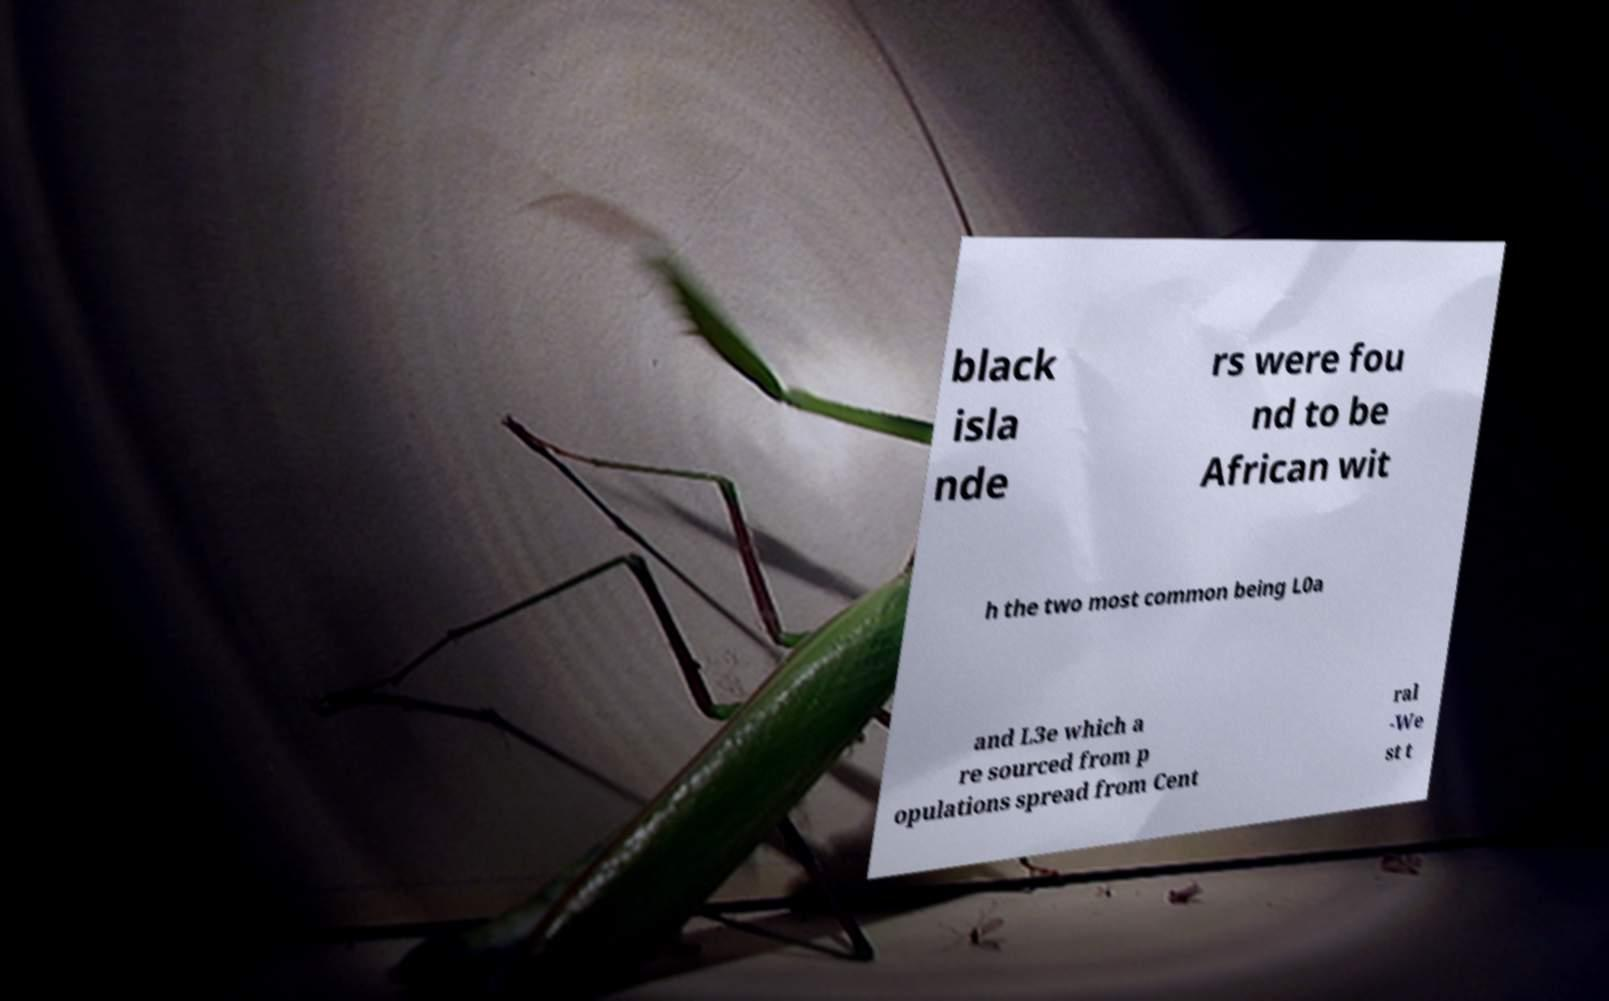Could you assist in decoding the text presented in this image and type it out clearly? black isla nde rs were fou nd to be African wit h the two most common being L0a and L3e which a re sourced from p opulations spread from Cent ral -We st t 